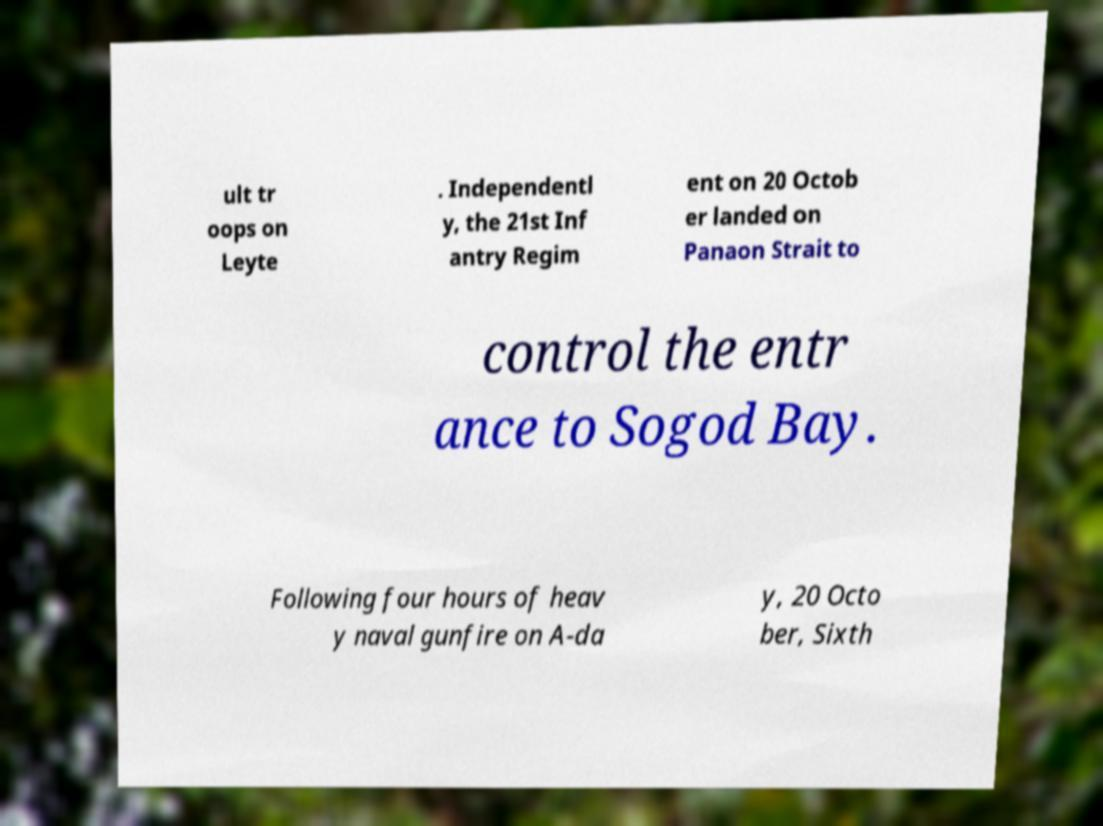There's text embedded in this image that I need extracted. Can you transcribe it verbatim? ult tr oops on Leyte . Independentl y, the 21st Inf antry Regim ent on 20 Octob er landed on Panaon Strait to control the entr ance to Sogod Bay. Following four hours of heav y naval gunfire on A-da y, 20 Octo ber, Sixth 